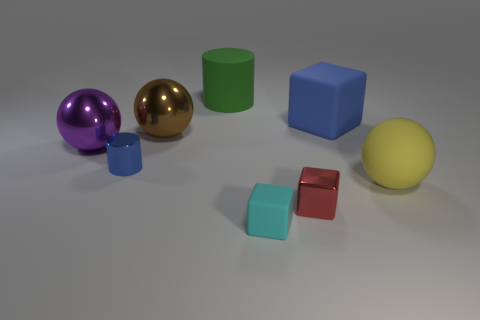What material is the purple thing that is the same shape as the big brown metallic object?
Make the answer very short. Metal. There is a big matte block; does it have the same color as the tiny shiny object that is to the left of the tiny red thing?
Make the answer very short. Yes. There is a purple thing that is the same size as the green rubber object; what material is it?
Offer a very short reply. Metal. Is there a tiny red object made of the same material as the blue cylinder?
Keep it short and to the point. Yes. How many metallic cubes are there?
Your answer should be very brief. 1. Is the material of the big green thing the same as the ball right of the rubber cylinder?
Offer a very short reply. Yes. What is the material of the cylinder that is the same color as the big cube?
Keep it short and to the point. Metal. What number of metal cylinders are the same color as the big rubber block?
Your answer should be very brief. 1. The green rubber cylinder is what size?
Provide a succinct answer. Large. Do the large purple metallic thing and the matte object right of the large matte cube have the same shape?
Your response must be concise. Yes. 